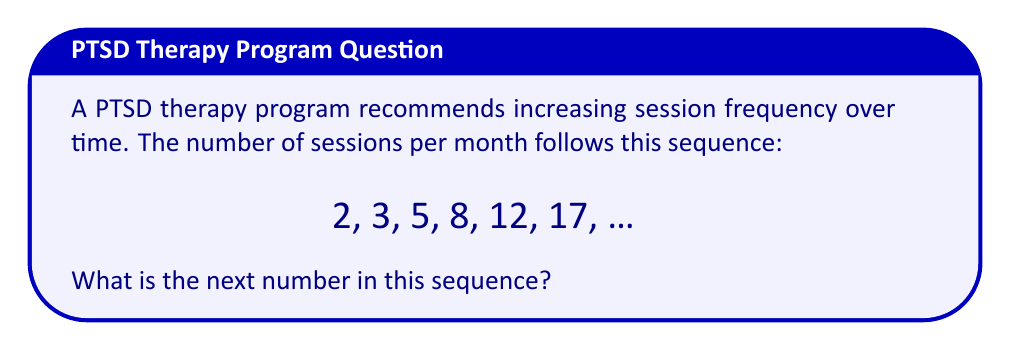Solve this math problem. To find the next number in the sequence, we need to identify the pattern:

1) First, let's calculate the differences between consecutive terms:
   $3 - 2 = 1$
   $5 - 3 = 2$
   $8 - 5 = 3$
   $12 - 8 = 4$
   $17 - 12 = 5$

2) We can see that the differences are increasing by 1 each time:
   1, 2, 3, 4, 5, ...

3) This suggests that the sequence follows the pattern of adding an increasing number each time.

4) To find the next term, we need to add the next number in the difference sequence (which would be 6) to the last term in our original sequence:

   $17 + 6 = 23$

Therefore, the next number in the sequence should be 23.

This pattern reflects a gradual increase in therapy session frequency, which might be beneficial for a person with PTSD as they progress through their treatment.
Answer: 23 